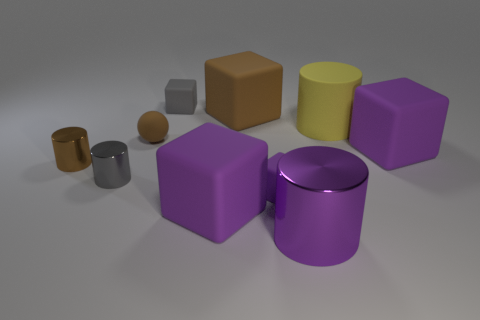Subtract all purple cylinders. How many cylinders are left? 3 Subtract all tiny cubes. How many cubes are left? 3 Add 8 large purple cubes. How many large purple cubes exist? 10 Subtract 0 blue cylinders. How many objects are left? 10 Subtract all cylinders. How many objects are left? 6 Subtract 1 spheres. How many spheres are left? 0 Subtract all purple cylinders. Subtract all brown spheres. How many cylinders are left? 3 Subtract all green cubes. How many blue cylinders are left? 0 Subtract all metal things. Subtract all blue cylinders. How many objects are left? 7 Add 3 tiny balls. How many tiny balls are left? 4 